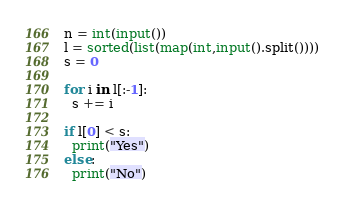Convert code to text. <code><loc_0><loc_0><loc_500><loc_500><_Python_>n = int(input())
l = sorted(list(map(int,input().split())))
s = 0
 
for i in l[:-1]:
  s += i
  
if l[0] < s:
  print("Yes")
else:
  print("No")</code> 